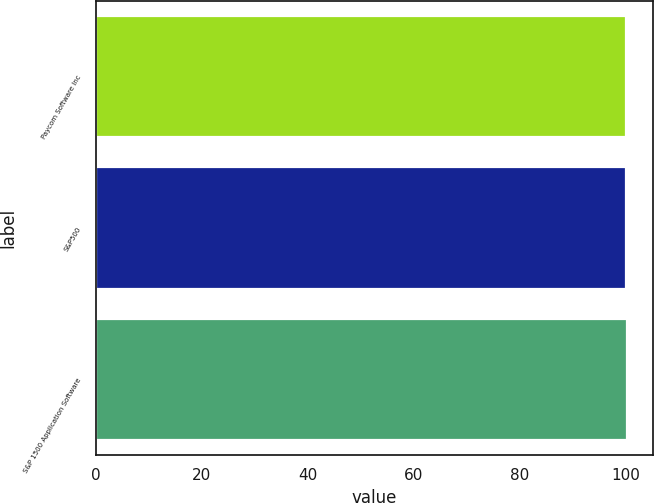Convert chart to OTSL. <chart><loc_0><loc_0><loc_500><loc_500><bar_chart><fcel>Paycom Software Inc<fcel>S&P500<fcel>S&P 1500 Application Software<nl><fcel>100<fcel>100.1<fcel>100.2<nl></chart> 